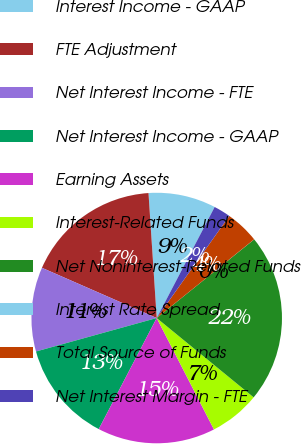Convert chart. <chart><loc_0><loc_0><loc_500><loc_500><pie_chart><fcel>Interest Income - GAAP<fcel>FTE Adjustment<fcel>Net Interest Income - FTE<fcel>Net Interest Income - GAAP<fcel>Earning Assets<fcel>Interest-Related Funds<fcel>Net Noninterest-Related Funds<fcel>Interest Rate Spread<fcel>Total Source of Funds<fcel>Net Interest Margin - FTE<nl><fcel>8.7%<fcel>17.39%<fcel>10.87%<fcel>13.04%<fcel>15.21%<fcel>6.53%<fcel>21.72%<fcel>0.01%<fcel>4.35%<fcel>2.18%<nl></chart> 